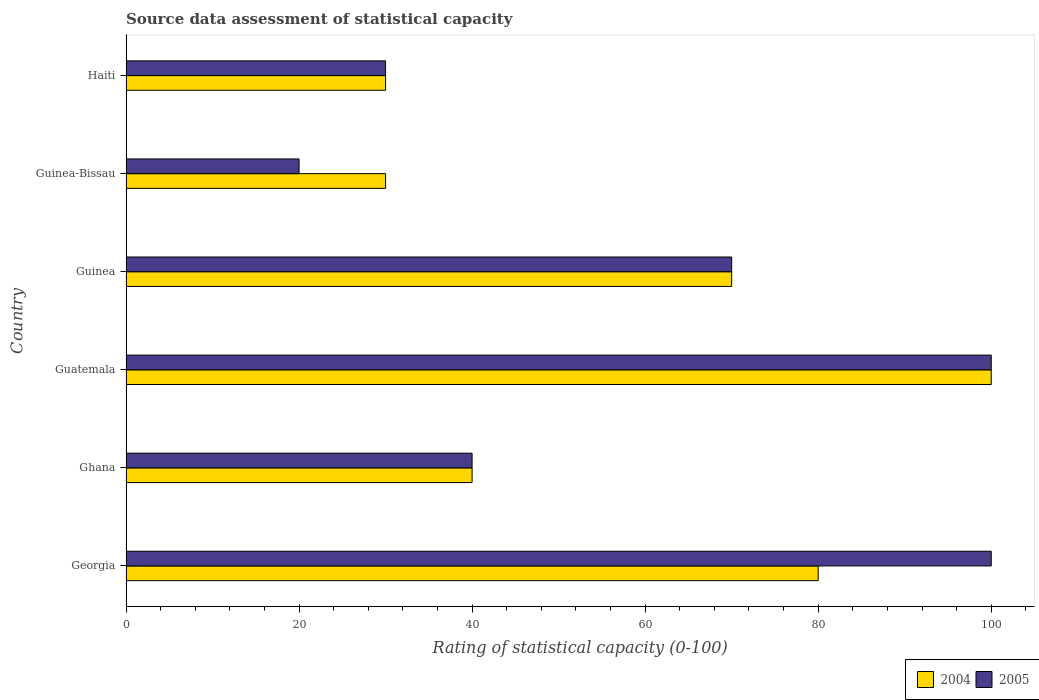Are the number of bars on each tick of the Y-axis equal?
Offer a very short reply. Yes. What is the label of the 2nd group of bars from the top?
Offer a very short reply. Guinea-Bissau. Across all countries, what is the minimum rating of statistical capacity in 2005?
Your response must be concise. 20. In which country was the rating of statistical capacity in 2004 maximum?
Keep it short and to the point. Guatemala. In which country was the rating of statistical capacity in 2004 minimum?
Provide a short and direct response. Guinea-Bissau. What is the total rating of statistical capacity in 2004 in the graph?
Provide a short and direct response. 350. What is the difference between the rating of statistical capacity in 2004 in Haiti and the rating of statistical capacity in 2005 in Guatemala?
Your answer should be compact. -70. In how many countries, is the rating of statistical capacity in 2005 greater than 4 ?
Your answer should be very brief. 6. What is the ratio of the rating of statistical capacity in 2004 in Georgia to that in Guinea?
Make the answer very short. 1.14. Is the difference between the rating of statistical capacity in 2004 in Guinea and Haiti greater than the difference between the rating of statistical capacity in 2005 in Guinea and Haiti?
Give a very brief answer. No. What is the difference between the highest and the second highest rating of statistical capacity in 2005?
Provide a succinct answer. 0. In how many countries, is the rating of statistical capacity in 2004 greater than the average rating of statistical capacity in 2004 taken over all countries?
Provide a succinct answer. 3. Is the sum of the rating of statistical capacity in 2004 in Guinea and Guinea-Bissau greater than the maximum rating of statistical capacity in 2005 across all countries?
Your answer should be very brief. No. What does the 1st bar from the top in Guinea-Bissau represents?
Give a very brief answer. 2005. What does the 1st bar from the bottom in Guatemala represents?
Provide a short and direct response. 2004. What is the difference between two consecutive major ticks on the X-axis?
Keep it short and to the point. 20. Does the graph contain any zero values?
Offer a terse response. No. Does the graph contain grids?
Your answer should be compact. No. How many legend labels are there?
Your answer should be very brief. 2. How are the legend labels stacked?
Your answer should be very brief. Horizontal. What is the title of the graph?
Provide a succinct answer. Source data assessment of statistical capacity. Does "1968" appear as one of the legend labels in the graph?
Your answer should be compact. No. What is the label or title of the X-axis?
Your answer should be compact. Rating of statistical capacity (0-100). What is the Rating of statistical capacity (0-100) of 2004 in Georgia?
Give a very brief answer. 80. What is the Rating of statistical capacity (0-100) in 2005 in Georgia?
Give a very brief answer. 100. What is the Rating of statistical capacity (0-100) in 2005 in Ghana?
Provide a succinct answer. 40. What is the Rating of statistical capacity (0-100) in 2004 in Guatemala?
Your response must be concise. 100. What is the Rating of statistical capacity (0-100) of 2004 in Guinea?
Provide a succinct answer. 70. What is the Rating of statistical capacity (0-100) of 2005 in Guinea?
Your response must be concise. 70. What is the Rating of statistical capacity (0-100) in 2005 in Guinea-Bissau?
Provide a short and direct response. 20. Across all countries, what is the maximum Rating of statistical capacity (0-100) in 2004?
Ensure brevity in your answer.  100. Across all countries, what is the maximum Rating of statistical capacity (0-100) in 2005?
Offer a terse response. 100. Across all countries, what is the minimum Rating of statistical capacity (0-100) of 2004?
Offer a very short reply. 30. Across all countries, what is the minimum Rating of statistical capacity (0-100) of 2005?
Keep it short and to the point. 20. What is the total Rating of statistical capacity (0-100) in 2004 in the graph?
Give a very brief answer. 350. What is the total Rating of statistical capacity (0-100) in 2005 in the graph?
Provide a succinct answer. 360. What is the difference between the Rating of statistical capacity (0-100) of 2004 in Georgia and that in Ghana?
Make the answer very short. 40. What is the difference between the Rating of statistical capacity (0-100) of 2005 in Georgia and that in Guatemala?
Your response must be concise. 0. What is the difference between the Rating of statistical capacity (0-100) in 2005 in Georgia and that in Guinea?
Provide a succinct answer. 30. What is the difference between the Rating of statistical capacity (0-100) of 2004 in Georgia and that in Guinea-Bissau?
Your answer should be very brief. 50. What is the difference between the Rating of statistical capacity (0-100) in 2004 in Georgia and that in Haiti?
Offer a very short reply. 50. What is the difference between the Rating of statistical capacity (0-100) of 2004 in Ghana and that in Guatemala?
Keep it short and to the point. -60. What is the difference between the Rating of statistical capacity (0-100) in 2005 in Ghana and that in Guatemala?
Keep it short and to the point. -60. What is the difference between the Rating of statistical capacity (0-100) in 2004 in Ghana and that in Guinea?
Offer a very short reply. -30. What is the difference between the Rating of statistical capacity (0-100) in 2004 in Ghana and that in Guinea-Bissau?
Give a very brief answer. 10. What is the difference between the Rating of statistical capacity (0-100) in 2005 in Ghana and that in Haiti?
Offer a very short reply. 10. What is the difference between the Rating of statistical capacity (0-100) in 2004 in Guatemala and that in Haiti?
Provide a short and direct response. 70. What is the difference between the Rating of statistical capacity (0-100) of 2005 in Guinea and that in Guinea-Bissau?
Your response must be concise. 50. What is the difference between the Rating of statistical capacity (0-100) of 2004 in Guinea and that in Haiti?
Keep it short and to the point. 40. What is the difference between the Rating of statistical capacity (0-100) in 2004 in Guinea-Bissau and that in Haiti?
Offer a terse response. 0. What is the difference between the Rating of statistical capacity (0-100) of 2004 in Georgia and the Rating of statistical capacity (0-100) of 2005 in Guatemala?
Ensure brevity in your answer.  -20. What is the difference between the Rating of statistical capacity (0-100) in 2004 in Georgia and the Rating of statistical capacity (0-100) in 2005 in Guinea-Bissau?
Provide a short and direct response. 60. What is the difference between the Rating of statistical capacity (0-100) of 2004 in Ghana and the Rating of statistical capacity (0-100) of 2005 in Guatemala?
Ensure brevity in your answer.  -60. What is the difference between the Rating of statistical capacity (0-100) in 2004 in Ghana and the Rating of statistical capacity (0-100) in 2005 in Guinea?
Your answer should be very brief. -30. What is the difference between the Rating of statistical capacity (0-100) in 2004 in Ghana and the Rating of statistical capacity (0-100) in 2005 in Haiti?
Give a very brief answer. 10. What is the difference between the Rating of statistical capacity (0-100) in 2004 in Guatemala and the Rating of statistical capacity (0-100) in 2005 in Guinea-Bissau?
Your answer should be very brief. 80. What is the difference between the Rating of statistical capacity (0-100) of 2004 in Guatemala and the Rating of statistical capacity (0-100) of 2005 in Haiti?
Make the answer very short. 70. What is the difference between the Rating of statistical capacity (0-100) in 2004 in Guinea and the Rating of statistical capacity (0-100) in 2005 in Guinea-Bissau?
Provide a short and direct response. 50. What is the difference between the Rating of statistical capacity (0-100) in 2004 in Guinea and the Rating of statistical capacity (0-100) in 2005 in Haiti?
Offer a very short reply. 40. What is the difference between the Rating of statistical capacity (0-100) of 2004 in Guinea-Bissau and the Rating of statistical capacity (0-100) of 2005 in Haiti?
Provide a succinct answer. 0. What is the average Rating of statistical capacity (0-100) in 2004 per country?
Keep it short and to the point. 58.33. What is the difference between the Rating of statistical capacity (0-100) in 2004 and Rating of statistical capacity (0-100) in 2005 in Georgia?
Keep it short and to the point. -20. What is the difference between the Rating of statistical capacity (0-100) in 2004 and Rating of statistical capacity (0-100) in 2005 in Ghana?
Keep it short and to the point. 0. What is the difference between the Rating of statistical capacity (0-100) of 2004 and Rating of statistical capacity (0-100) of 2005 in Guinea?
Offer a very short reply. 0. What is the ratio of the Rating of statistical capacity (0-100) in 2005 in Georgia to that in Guatemala?
Offer a very short reply. 1. What is the ratio of the Rating of statistical capacity (0-100) in 2005 in Georgia to that in Guinea?
Make the answer very short. 1.43. What is the ratio of the Rating of statistical capacity (0-100) in 2004 in Georgia to that in Guinea-Bissau?
Offer a very short reply. 2.67. What is the ratio of the Rating of statistical capacity (0-100) of 2004 in Georgia to that in Haiti?
Make the answer very short. 2.67. What is the ratio of the Rating of statistical capacity (0-100) of 2004 in Ghana to that in Guatemala?
Your response must be concise. 0.4. What is the ratio of the Rating of statistical capacity (0-100) in 2004 in Guatemala to that in Guinea?
Give a very brief answer. 1.43. What is the ratio of the Rating of statistical capacity (0-100) of 2005 in Guatemala to that in Guinea?
Offer a terse response. 1.43. What is the ratio of the Rating of statistical capacity (0-100) of 2004 in Guatemala to that in Haiti?
Offer a very short reply. 3.33. What is the ratio of the Rating of statistical capacity (0-100) in 2005 in Guatemala to that in Haiti?
Offer a very short reply. 3.33. What is the ratio of the Rating of statistical capacity (0-100) in 2004 in Guinea to that in Guinea-Bissau?
Ensure brevity in your answer.  2.33. What is the ratio of the Rating of statistical capacity (0-100) in 2004 in Guinea to that in Haiti?
Provide a short and direct response. 2.33. What is the ratio of the Rating of statistical capacity (0-100) of 2005 in Guinea to that in Haiti?
Your answer should be compact. 2.33. What is the ratio of the Rating of statistical capacity (0-100) in 2004 in Guinea-Bissau to that in Haiti?
Make the answer very short. 1. What is the difference between the highest and the second highest Rating of statistical capacity (0-100) of 2005?
Give a very brief answer. 0. 